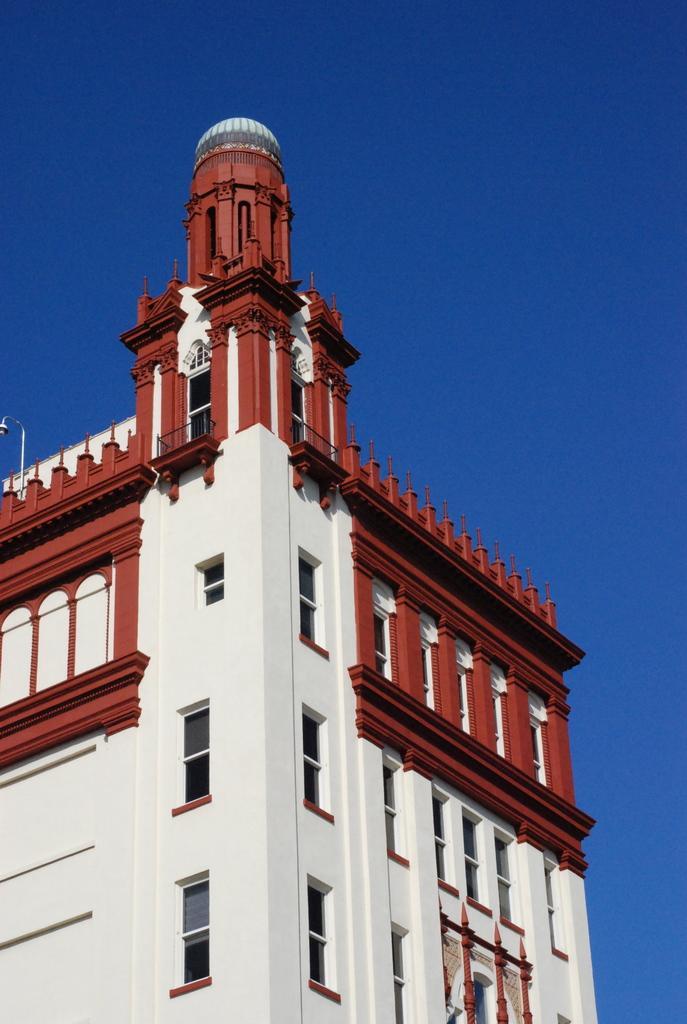Can you describe this image briefly? In the image there is a building on the left side and above its sky. 